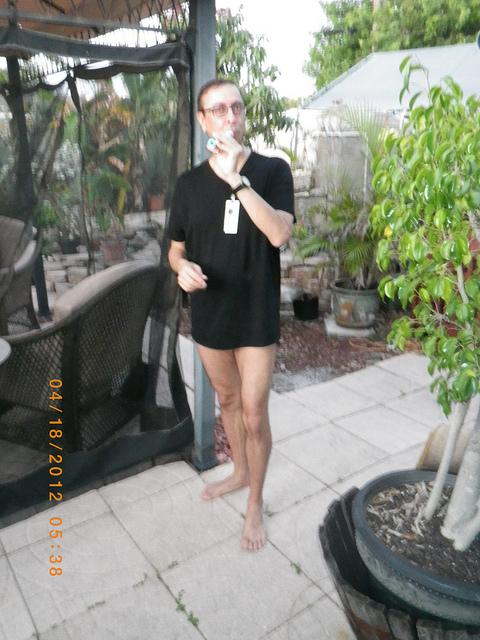Who is likely taking this picture in relation to the person who poses?

Choices:
A) enemy
B) spy
C) news team
D) intimate friend intimate friend 